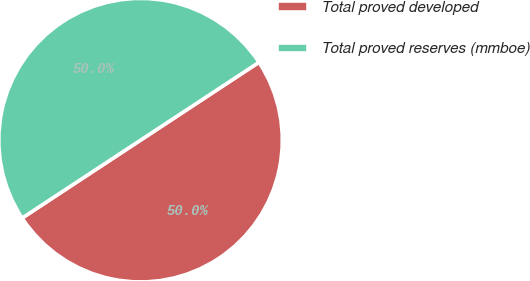Convert chart. <chart><loc_0><loc_0><loc_500><loc_500><pie_chart><fcel>Total proved developed<fcel>Total proved reserves (mmboe)<nl><fcel>50.0%<fcel>50.0%<nl></chart> 